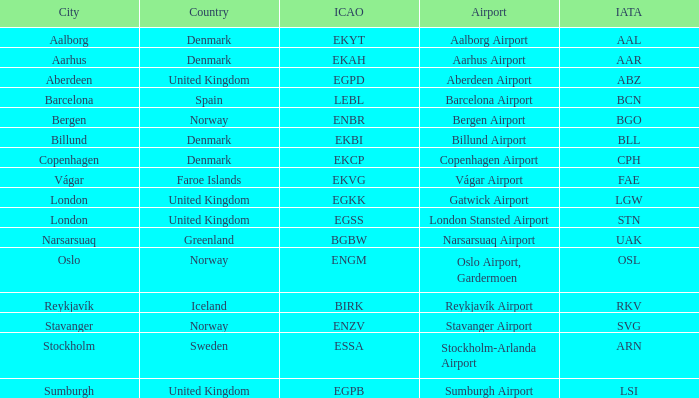What airport has an ICAO of Birk? Reykjavík Airport. 